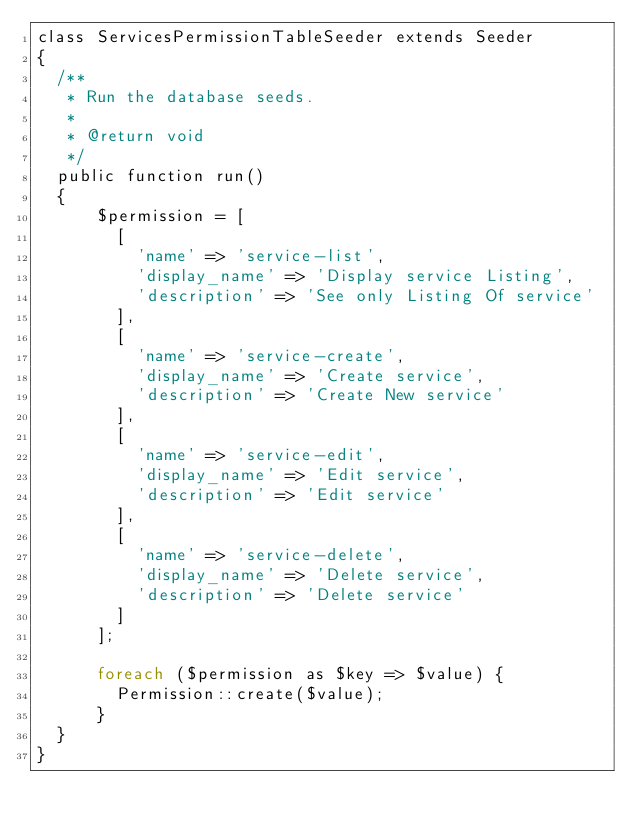<code> <loc_0><loc_0><loc_500><loc_500><_PHP_>class ServicesPermissionTableSeeder extends Seeder
{
  /**
   * Run the database seeds.
   *
   * @return void
   */
  public function run()
  {
      $permission = [
        [
          'name' => 'service-list',
          'display_name' => 'Display service Listing',
          'description' => 'See only Listing Of service'
        ],
        [
          'name' => 'service-create',
          'display_name' => 'Create service',
          'description' => 'Create New service'
        ],
        [
          'name' => 'service-edit',
          'display_name' => 'Edit service',
          'description' => 'Edit service'
        ],
        [
          'name' => 'service-delete',
          'display_name' => 'Delete service',
          'description' => 'Delete service'
        ]
      ];

      foreach ($permission as $key => $value) {
        Permission::create($value);
      }
  }
}
</code> 